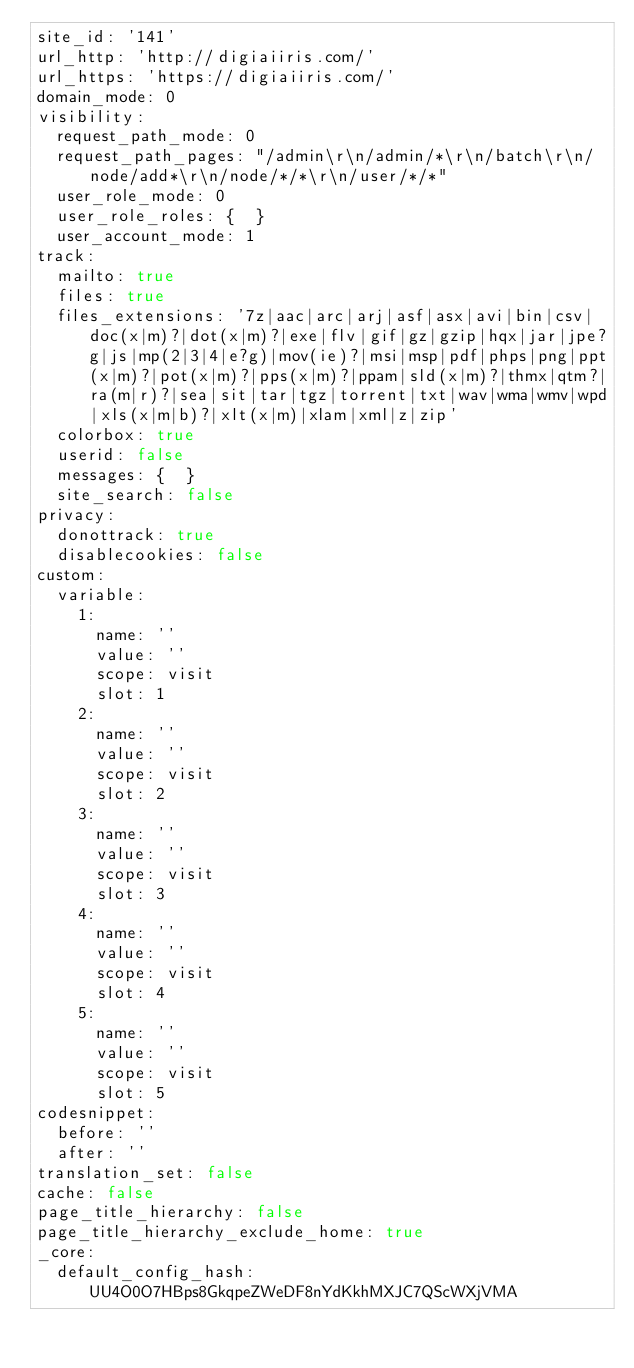Convert code to text. <code><loc_0><loc_0><loc_500><loc_500><_YAML_>site_id: '141'
url_http: 'http://digiaiiris.com/'
url_https: 'https://digiaiiris.com/'
domain_mode: 0
visibility:
  request_path_mode: 0
  request_path_pages: "/admin\r\n/admin/*\r\n/batch\r\n/node/add*\r\n/node/*/*\r\n/user/*/*"
  user_role_mode: 0
  user_role_roles: {  }
  user_account_mode: 1
track:
  mailto: true
  files: true
  files_extensions: '7z|aac|arc|arj|asf|asx|avi|bin|csv|doc(x|m)?|dot(x|m)?|exe|flv|gif|gz|gzip|hqx|jar|jpe?g|js|mp(2|3|4|e?g)|mov(ie)?|msi|msp|pdf|phps|png|ppt(x|m)?|pot(x|m)?|pps(x|m)?|ppam|sld(x|m)?|thmx|qtm?|ra(m|r)?|sea|sit|tar|tgz|torrent|txt|wav|wma|wmv|wpd|xls(x|m|b)?|xlt(x|m)|xlam|xml|z|zip'
  colorbox: true
  userid: false
  messages: {  }
  site_search: false
privacy:
  donottrack: true
  disablecookies: false
custom:
  variable:
    1:
      name: ''
      value: ''
      scope: visit
      slot: 1
    2:
      name: ''
      value: ''
      scope: visit
      slot: 2
    3:
      name: ''
      value: ''
      scope: visit
      slot: 3
    4:
      name: ''
      value: ''
      scope: visit
      slot: 4
    5:
      name: ''
      value: ''
      scope: visit
      slot: 5
codesnippet:
  before: ''
  after: ''
translation_set: false
cache: false
page_title_hierarchy: false
page_title_hierarchy_exclude_home: true
_core:
  default_config_hash: UU4O0O7HBps8GkqpeZWeDF8nYdKkhMXJC7QScWXjVMA
</code> 